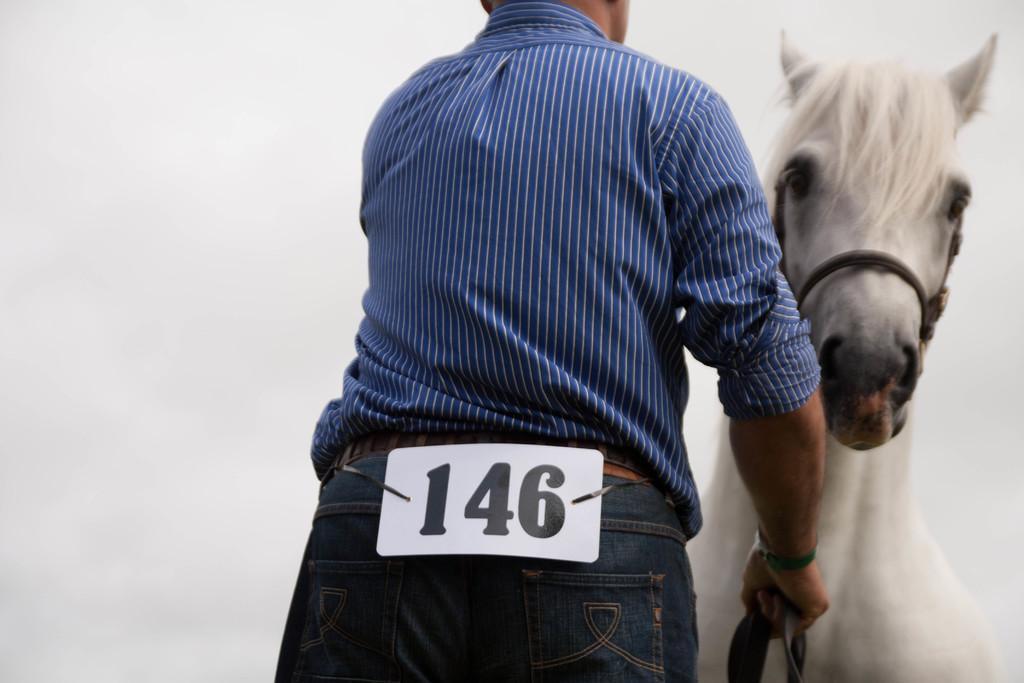How would you summarize this image in a sentence or two? Man holding horse. 